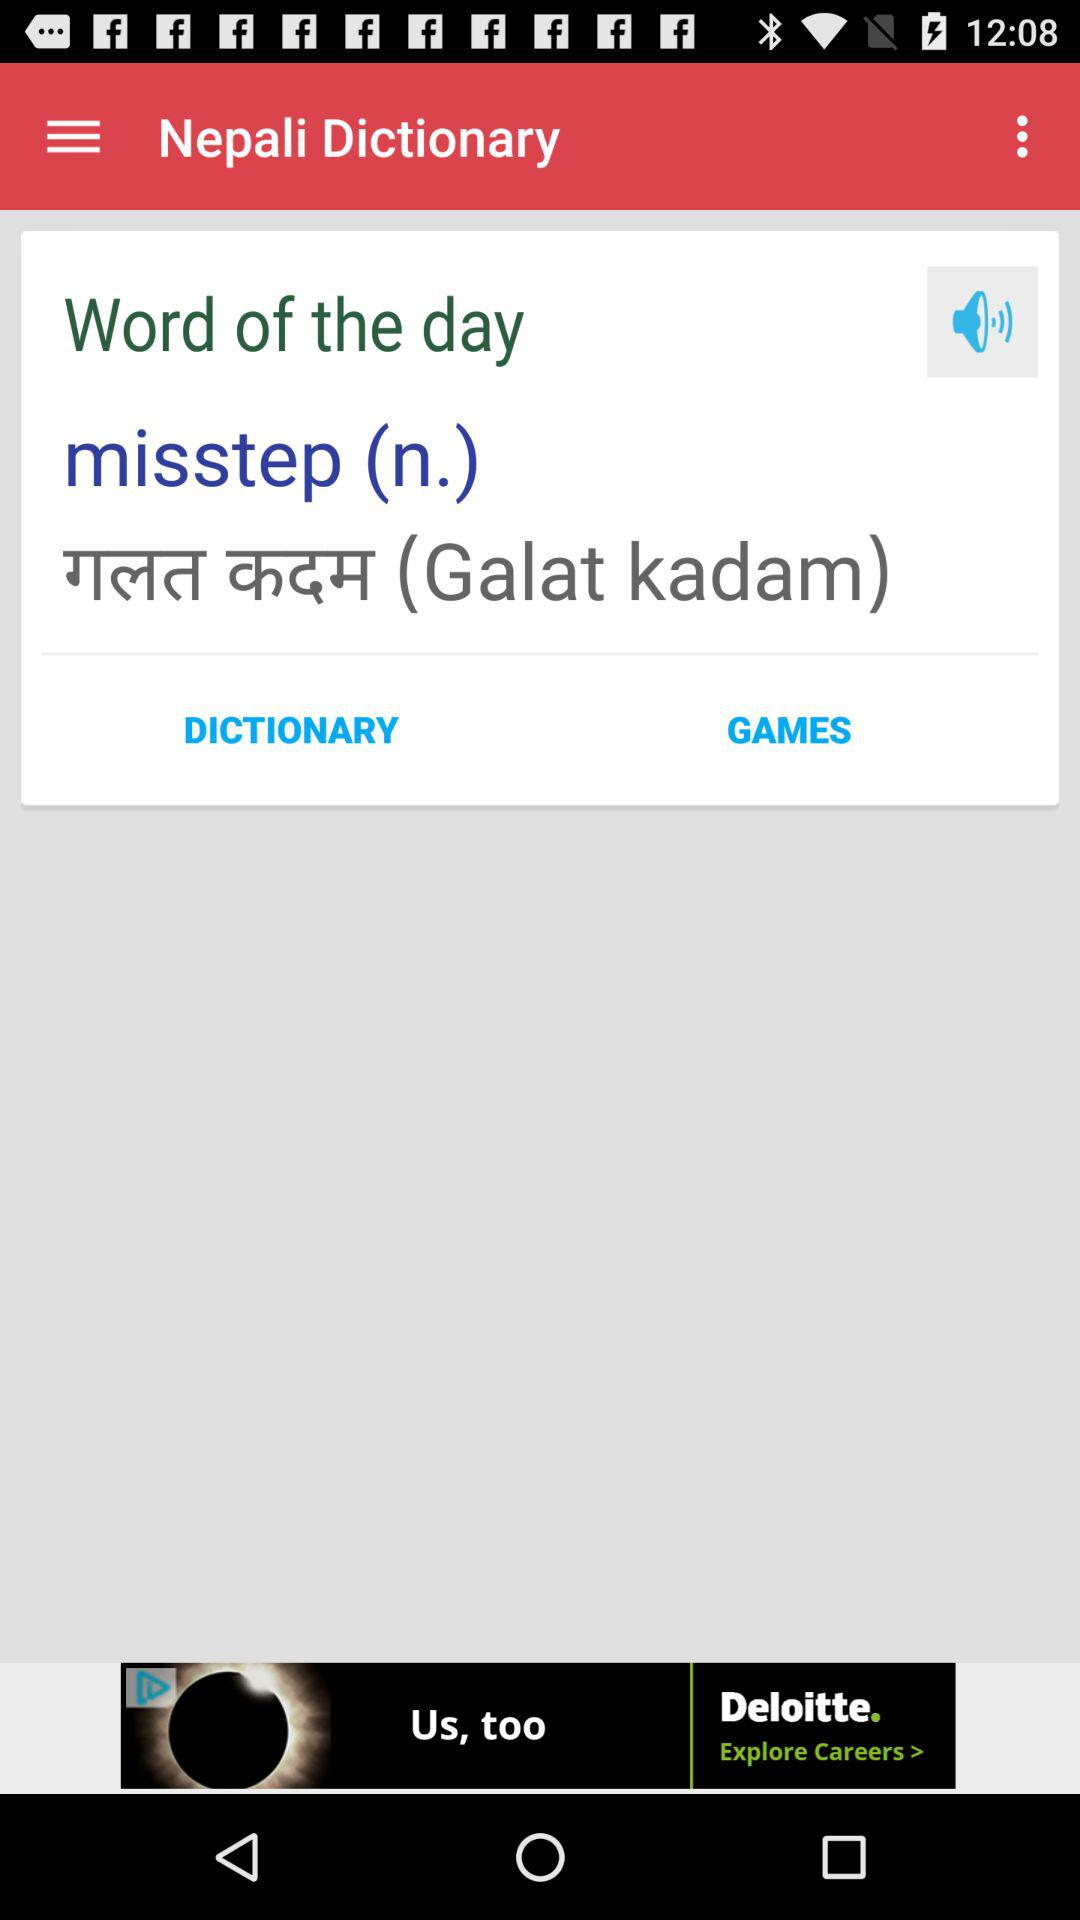What is the word of the day? The word of the day is "misstep". 